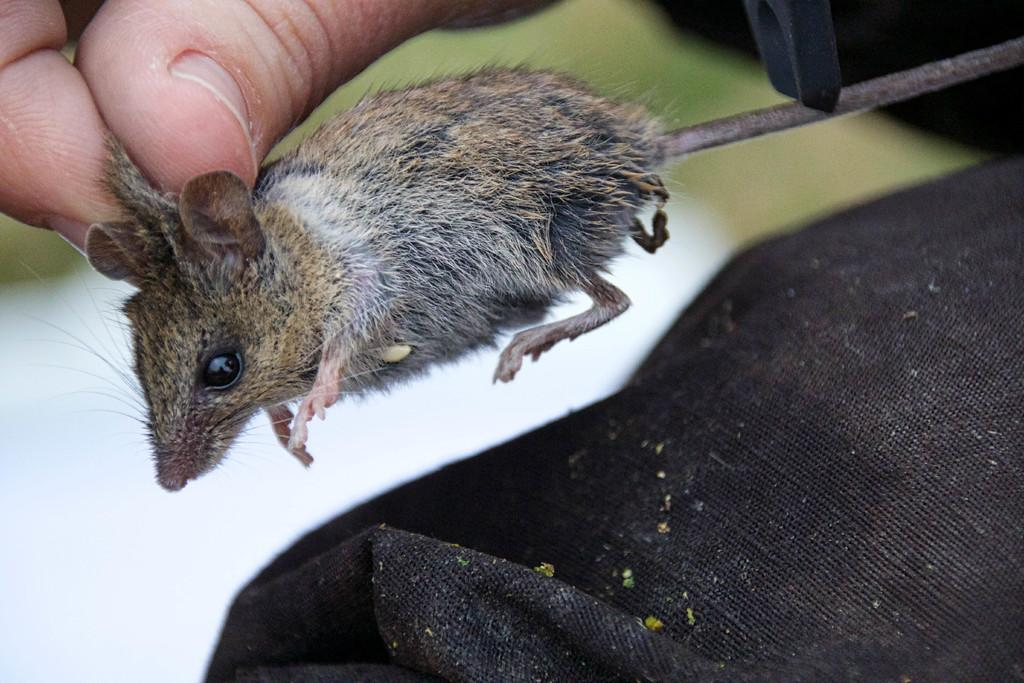What animal is present in the image? There is a rat in the image. What body parts of a person can be seen in the image? Person fingers are visible in the image. What colors are used in the background of the image? The background of the image is white and black. What type of lunchroom can be seen in the image? There is no lunchroom present in the image. 